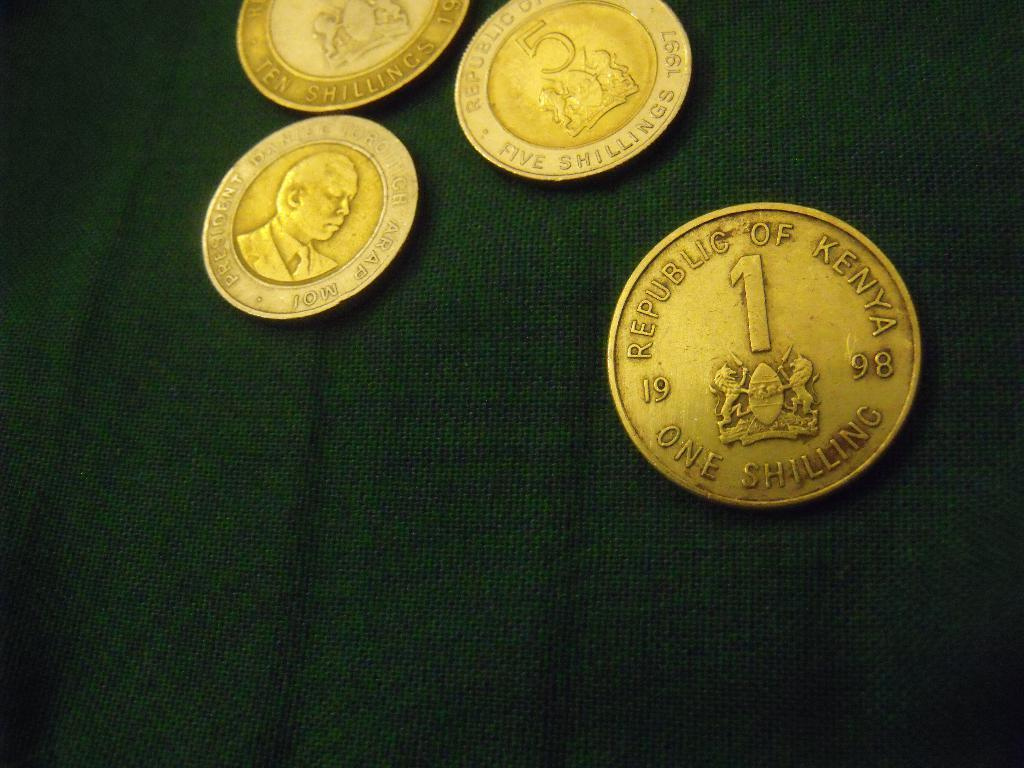Provide a one-sentence caption for the provided image. Several gold coins with the closests one from the Republic of Kenya worth one shilling from 1998. 